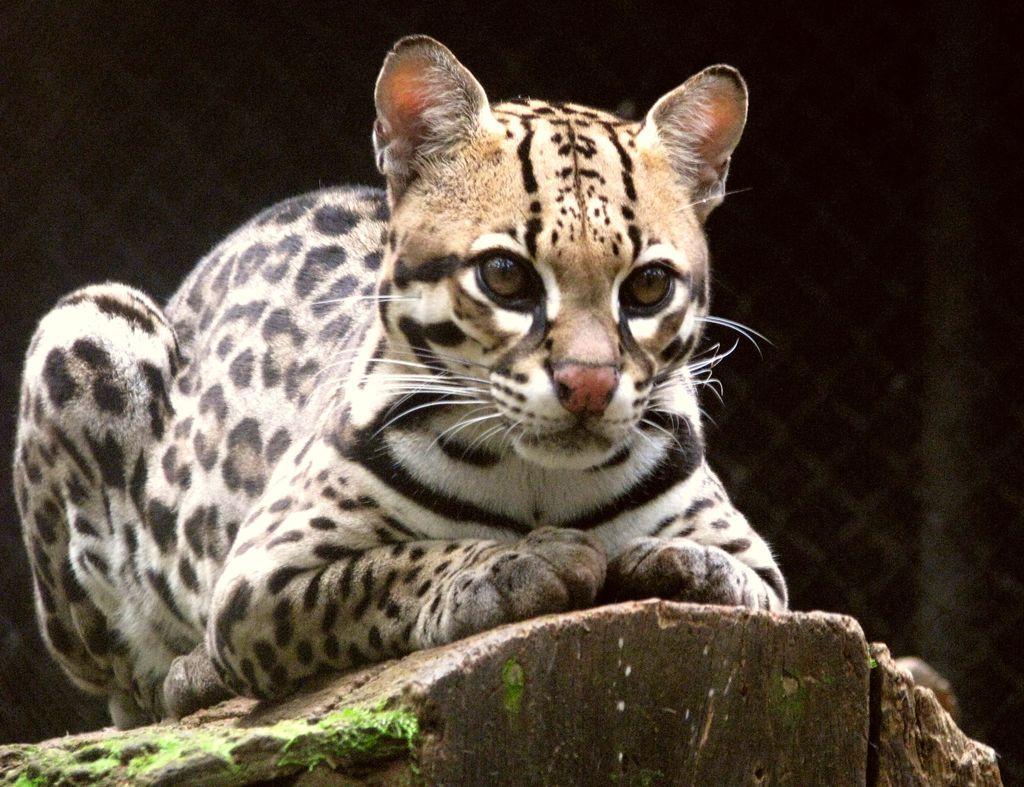Please provide a concise description of this image. In this picture I can see there is an animal sitting on the rock, there is a fence in the backdrop and it is a bit dark. 